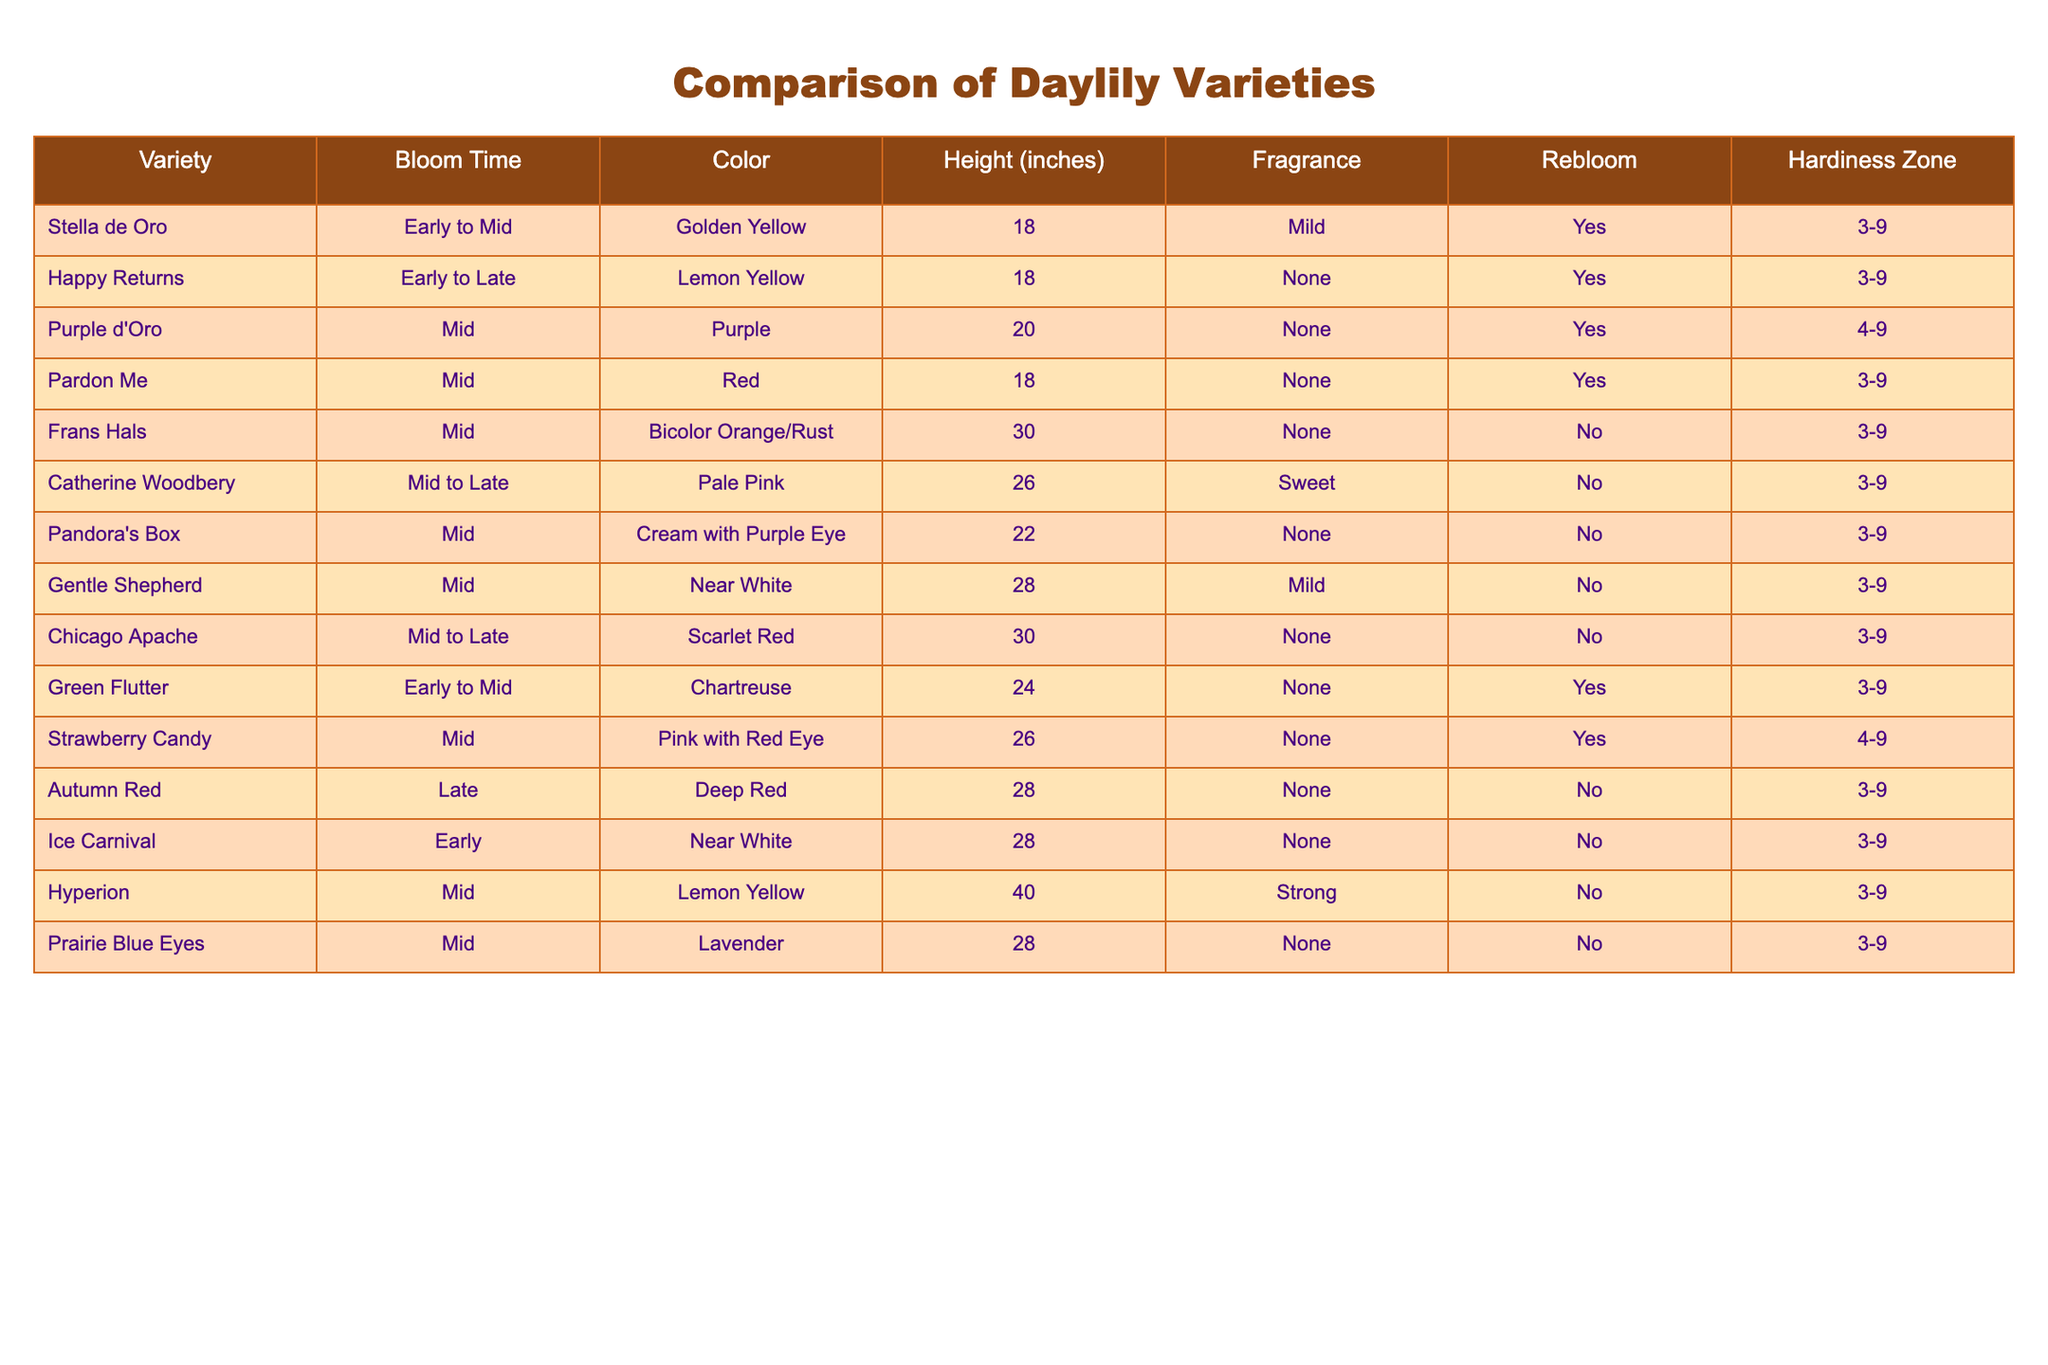What is the bloom time of 'Stella de Oro'? According to the table, the bloom time for 'Stella de Oro' is listed as "Early to Mid".
Answer: Early to Mid Which daylily varieties are in the mid bloom time category? The daylily varieties listed under the mid bloom time category are 'Purple d'Oro', 'Pardon Me', 'Frans Hals', 'Catherine Woodbery', 'Pandora's Box', 'Gentle Shepherd', 'Chicago Apache', 'Strawberry Candy', 'Hyperion', and 'Prairie Blue Eyes'.
Answer: 10 varieties What is the height of the 'Hyperion' variety? The height of the 'Hyperion' variety is indicated in the table as 40 inches.
Answer: 40 inches Is 'Happy Returns' fragrant? The table specifies that 'Happy Returns' has "None" listed under the fragrance column, which means it is not fragrant.
Answer: No How many varieties have a hardiness zone of "3-9" and are also fragrant? The varieties with a hardiness zone of "3-9" that are fragrant are 'Stella de Oro' (Mild), 'Green Flutter' (None), and 'Strawberry Candy' (None). Therefore, there are three varieties that meet these criteria.
Answer: 3 Which variety has the tallest height and what is that height? Upon reviewing the heights in the table, 'Hyperion' is the tallest variety at 40 inches.
Answer: 40 inches What colors are represented by the varieties that have a mid bloom time? From the data, the colors for mid bloom time varieties include Purple, Red, Bicolor Orange/Rust, Pale Pink, Cream with Purple Eye, Near White, Scarlet Red, Pink with Red Eye, Lavender, and Lemon Yellow.
Answer: 10 colors How many varieties are both reblooming and in the early to mid bloom time category? The varieties that are reblooming and fall into the early to mid bloom time category are 'Stella de Oro', 'Happy Returns', and 'Green Flutter', totaling three varieties.
Answer: 3 